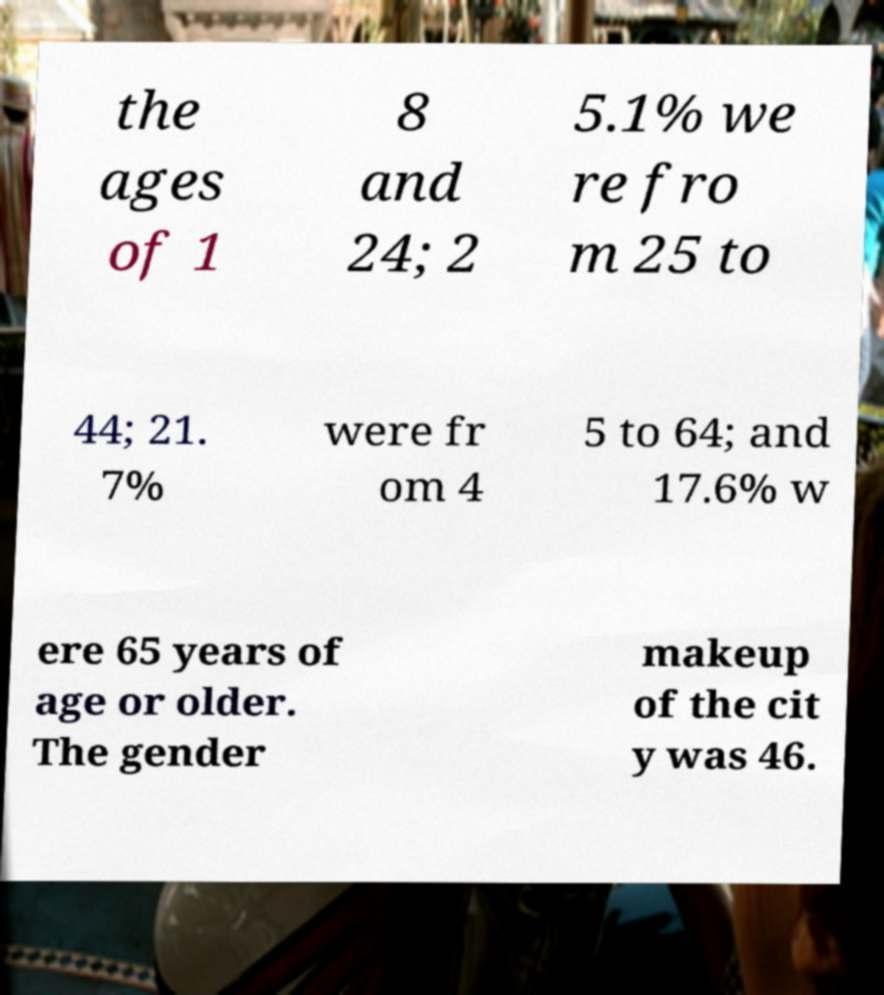Please read and relay the text visible in this image. What does it say? the ages of 1 8 and 24; 2 5.1% we re fro m 25 to 44; 21. 7% were fr om 4 5 to 64; and 17.6% w ere 65 years of age or older. The gender makeup of the cit y was 46. 